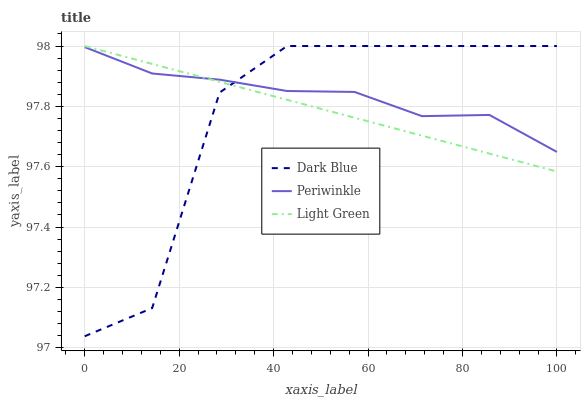Does Dark Blue have the minimum area under the curve?
Answer yes or no. Yes. Does Periwinkle have the maximum area under the curve?
Answer yes or no. Yes. Does Light Green have the minimum area under the curve?
Answer yes or no. No. Does Light Green have the maximum area under the curve?
Answer yes or no. No. Is Light Green the smoothest?
Answer yes or no. Yes. Is Dark Blue the roughest?
Answer yes or no. Yes. Is Periwinkle the smoothest?
Answer yes or no. No. Is Periwinkle the roughest?
Answer yes or no. No. Does Dark Blue have the lowest value?
Answer yes or no. Yes. Does Light Green have the lowest value?
Answer yes or no. No. Does Light Green have the highest value?
Answer yes or no. Yes. Does Periwinkle have the highest value?
Answer yes or no. No. Does Dark Blue intersect Periwinkle?
Answer yes or no. Yes. Is Dark Blue less than Periwinkle?
Answer yes or no. No. Is Dark Blue greater than Periwinkle?
Answer yes or no. No. 